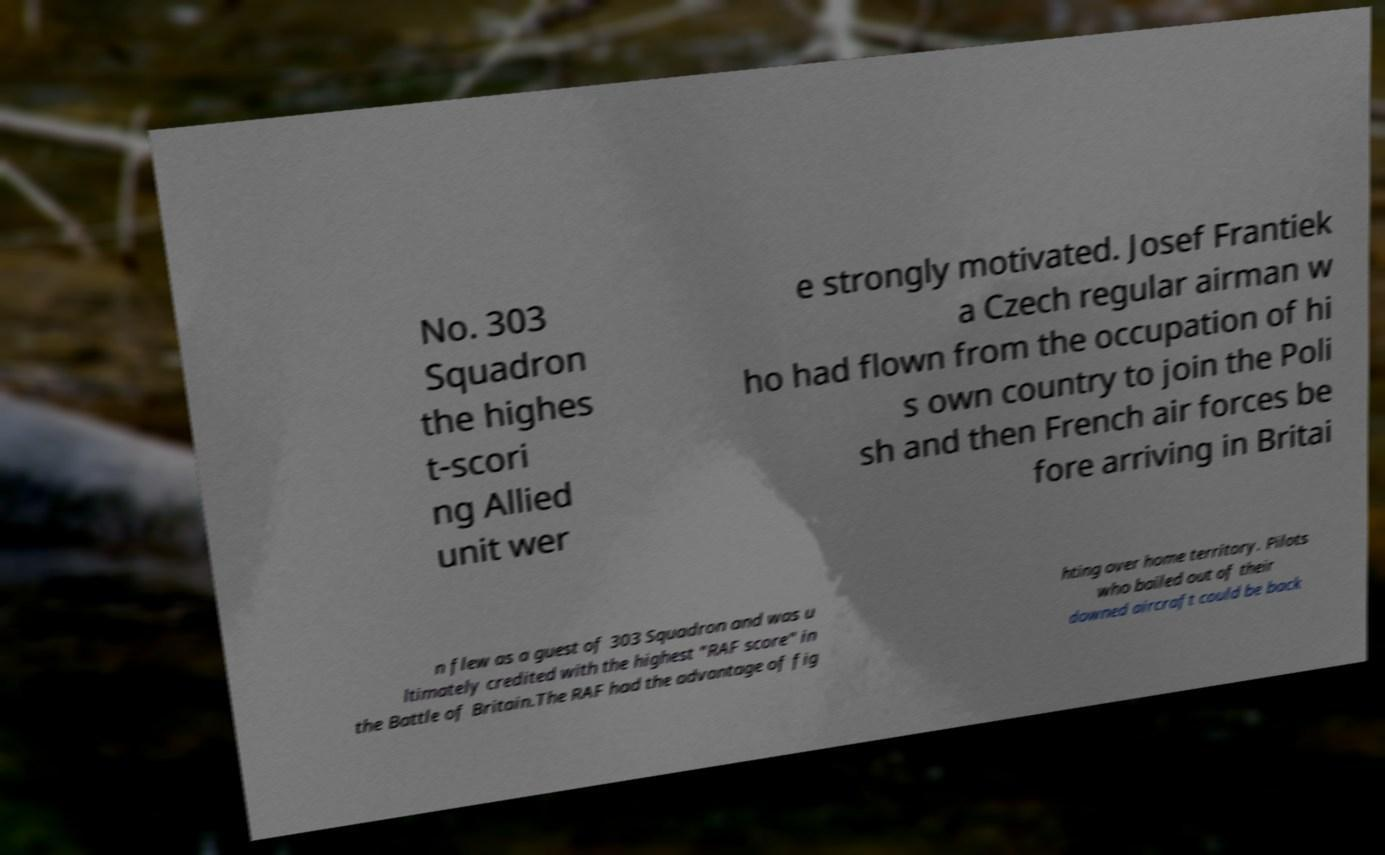There's text embedded in this image that I need extracted. Can you transcribe it verbatim? No. 303 Squadron the highes t-scori ng Allied unit wer e strongly motivated. Josef Frantiek a Czech regular airman w ho had flown from the occupation of hi s own country to join the Poli sh and then French air forces be fore arriving in Britai n flew as a guest of 303 Squadron and was u ltimately credited with the highest "RAF score" in the Battle of Britain.The RAF had the advantage of fig hting over home territory. Pilots who bailed out of their downed aircraft could be back 